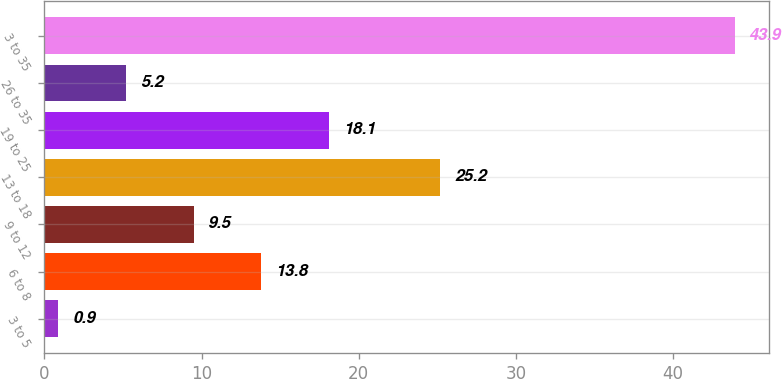Convert chart. <chart><loc_0><loc_0><loc_500><loc_500><bar_chart><fcel>3 to 5<fcel>6 to 8<fcel>9 to 12<fcel>13 to 18<fcel>19 to 25<fcel>26 to 35<fcel>3 to 35<nl><fcel>0.9<fcel>13.8<fcel>9.5<fcel>25.2<fcel>18.1<fcel>5.2<fcel>43.9<nl></chart> 